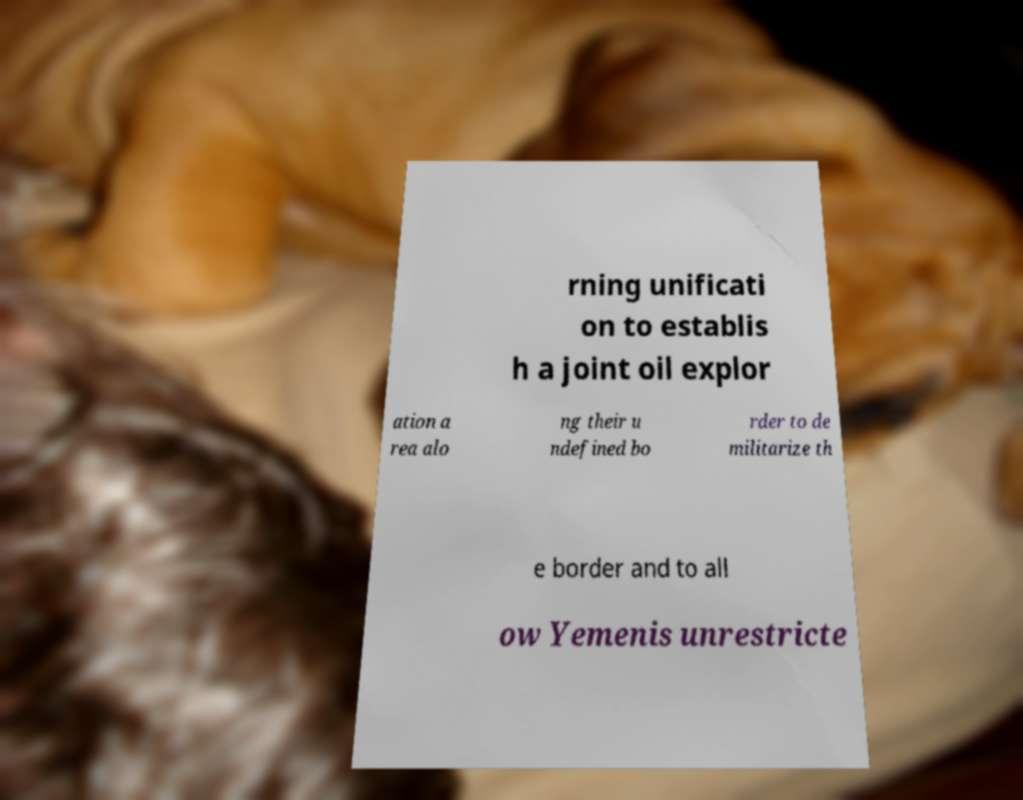Can you accurately transcribe the text from the provided image for me? rning unificati on to establis h a joint oil explor ation a rea alo ng their u ndefined bo rder to de militarize th e border and to all ow Yemenis unrestricte 